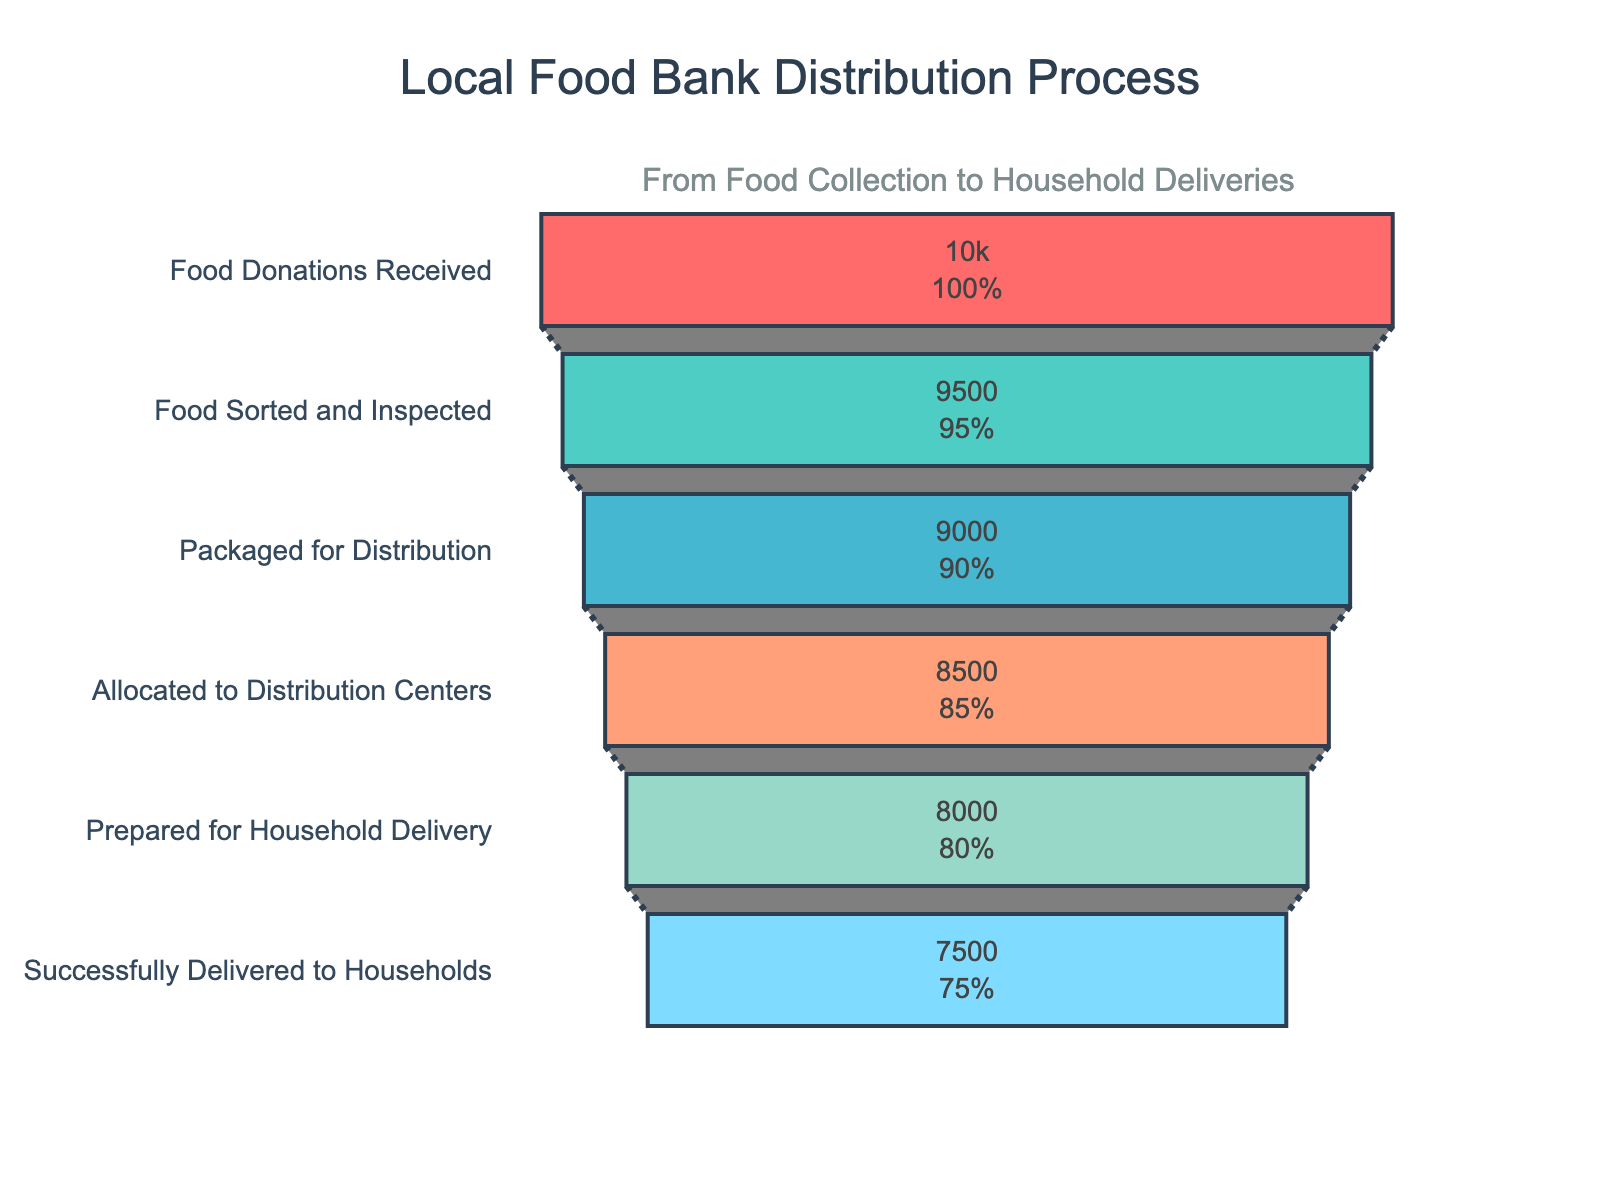What is the title of the funnel chart? Look at the header of the funnel chart. It indicates what the figure represents.
Answer: Local Food Bank Distribution Process How many steps are there in the food bank distribution process? Count the number of different steps listed in the chart.
Answer: 6 What color is used for the 'Food Donations Received' step? Identify the color associated with the first step in the funnel chart.
Answer: Red (#FF6B6B) How many items were successfully delivered to households? Refer to the value associated with the final step in the process: "Successfully Delivered to Households".
Answer: 7500 What is the difference between the 'Food Donations Received' and the 'Successfully Delivered to Households' values? Subtract the number of successfully delivered items from the number of food donations received: 10000 - 7500.
Answer: 2500 Which step has the least number of items and what is that number? Look for the step with the smallest value and note the step name and number.
Answer: Successfully Delivered to Households, 7500 How many items were prepared for household delivery? Check the value for the step titled "Prepared for Household Delivery."
Answer: 8000 Which step saw the largest drop in the number of items compared to the previous step? Calculate the differences between each successive step and identify the largest difference: Food Donations Received - Food Sorted and Inspected (500), Food Sorted and Inspected - Packaged for Distribution (500), Packaged for Distribution - Allocated to Distribution Centers (500), Allocated to Distribution Centers - Prepared for Household Delivery (500), Prepared for Household Delivery - Successfully Delivered to Households (500).
Answer: Food Donations Received to Food Sorted and Inspected, 500 By what percentage do the number of items reduce from the 'Food Sorted and Inspected' step to the 'Packaged for Distribution' step? Find the percentage reduction: ((9500 - 9000) / 9500) * 100 = 5.26%.
Answer: 5.26% How many items were allocated to distribution centers if 85% of the received donations were usable? Calculate 85% of the "Food Donations Received" value: 0.85 * 10000.
Answer: 8500 